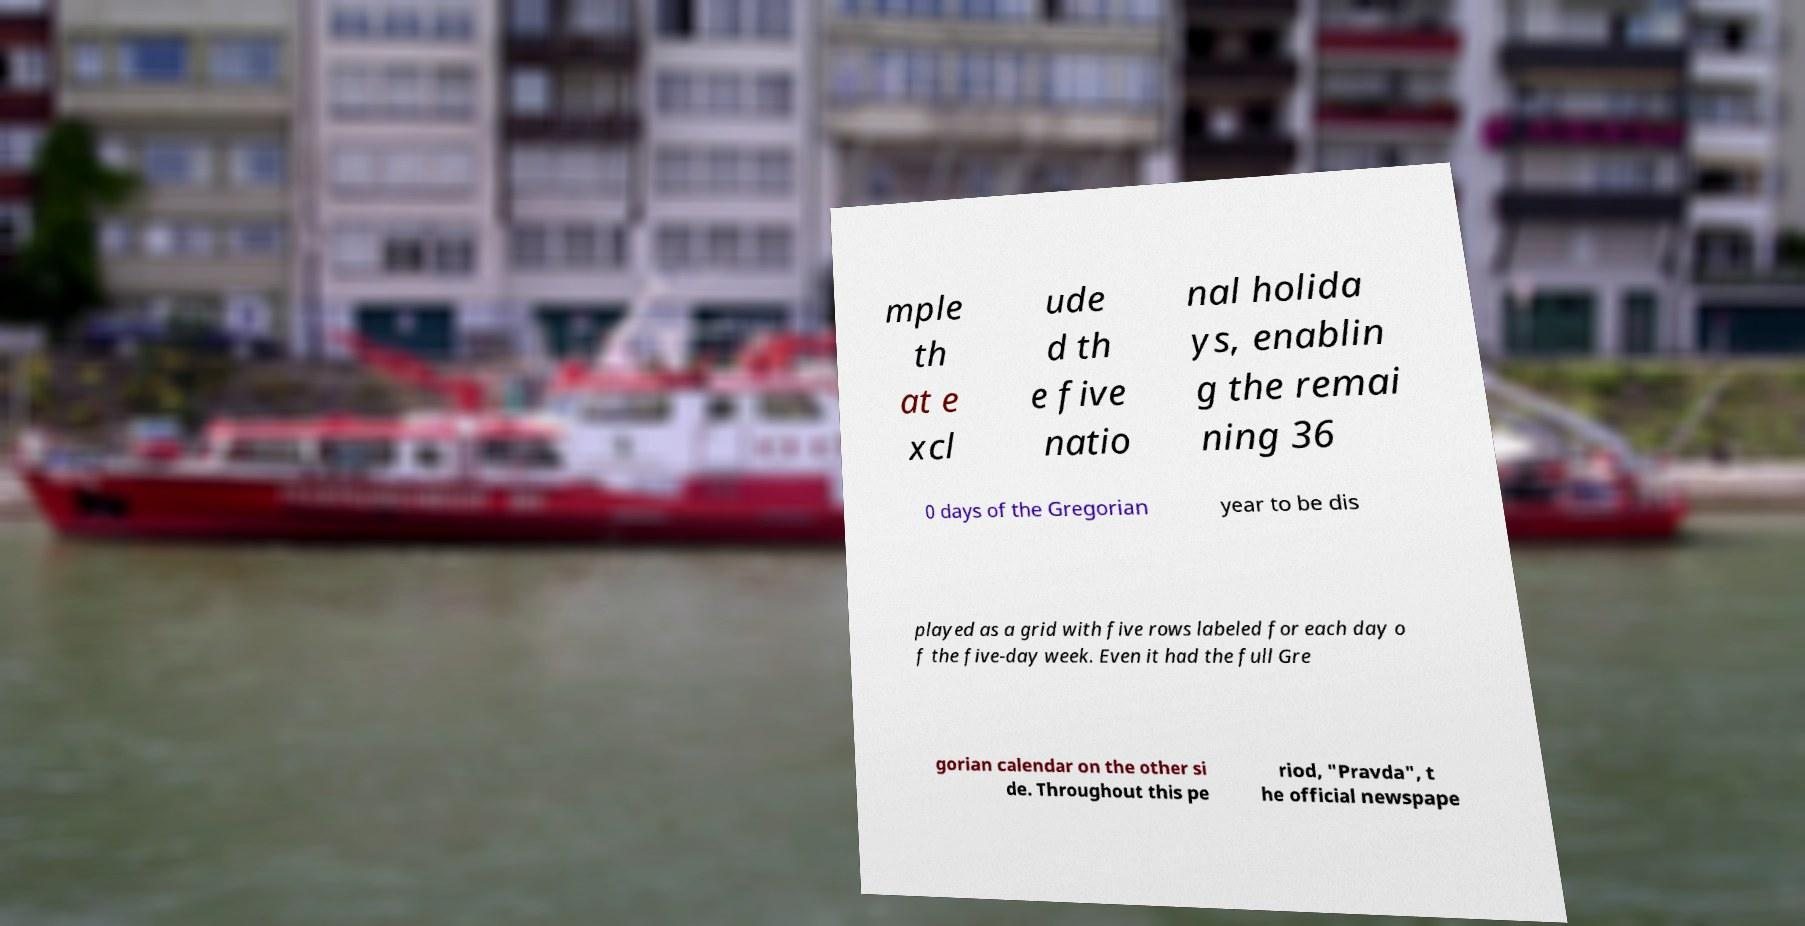Please read and relay the text visible in this image. What does it say? mple th at e xcl ude d th e five natio nal holida ys, enablin g the remai ning 36 0 days of the Gregorian year to be dis played as a grid with five rows labeled for each day o f the five-day week. Even it had the full Gre gorian calendar on the other si de. Throughout this pe riod, "Pravda", t he official newspape 